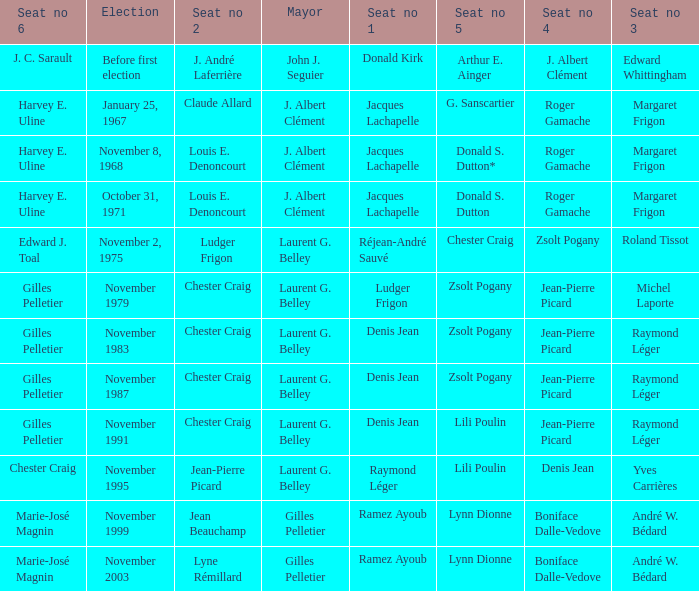Who is seat no 1 when the mayor was john j. seguier Donald Kirk. 